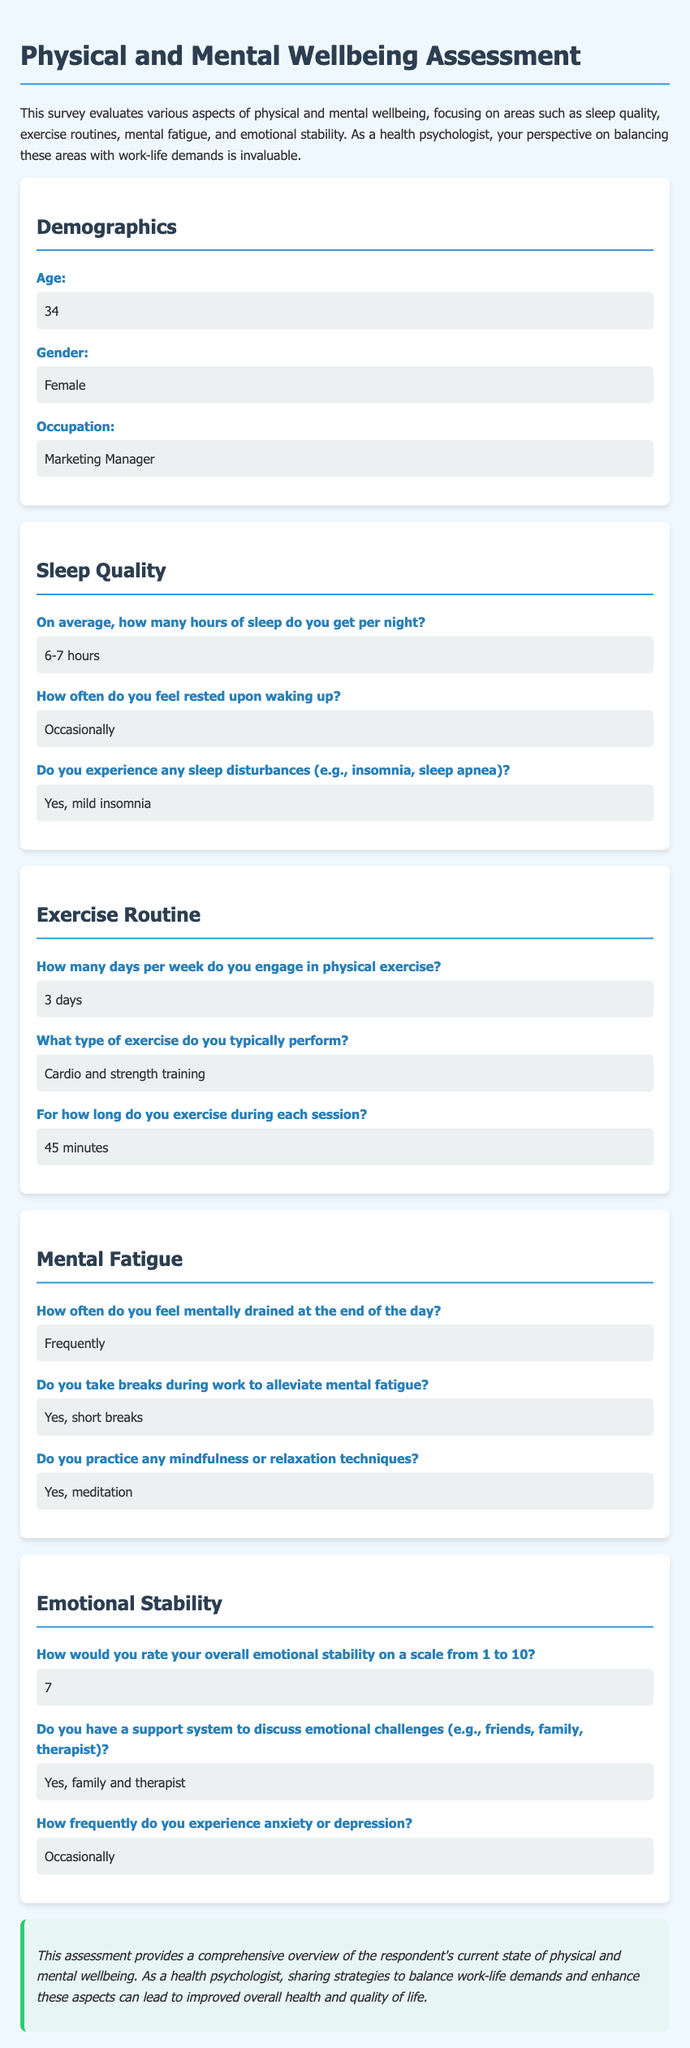What is the age of the respondent? The age of the respondent is stated in the demographics section of the document.
Answer: 34 What is the occupation of the respondent? The occupation is listed under the demographics section, detailing the respondent's job role.
Answer: Marketing Manager How many hours of sleep does the respondent get per night? The average hours of sleep is specified in the sleep quality section of the document.
Answer: 6-7 hours How often does the respondent engage in physical exercise? This information about exercise frequency is provided in the exercise routine section.
Answer: 3 days What type of exercise does the respondent typically perform? The type of exercise is described in the exercise routine section.
Answer: Cardio and strength training On a scale from 1 to 10, how does the respondent rate their emotional stability? The rating of emotional stability is given in the emotional stability section of the document.
Answer: 7 How frequently does the respondent experience anxiety or depression? This information can be found in the emotional stability section, which addresses emotional challenges faced by the respondent.
Answer: Occasionally Does the respondent practice any mindfulness techniques? The practice of mindfulness techniques is mentioned in the mental fatigue section of the document.
Answer: Yes, meditation How often does the respondent feel mentally drained at the end of the day? This frequency is stated in the mental fatigue section, indicating the respondent's experience after a workday.
Answer: Frequently 